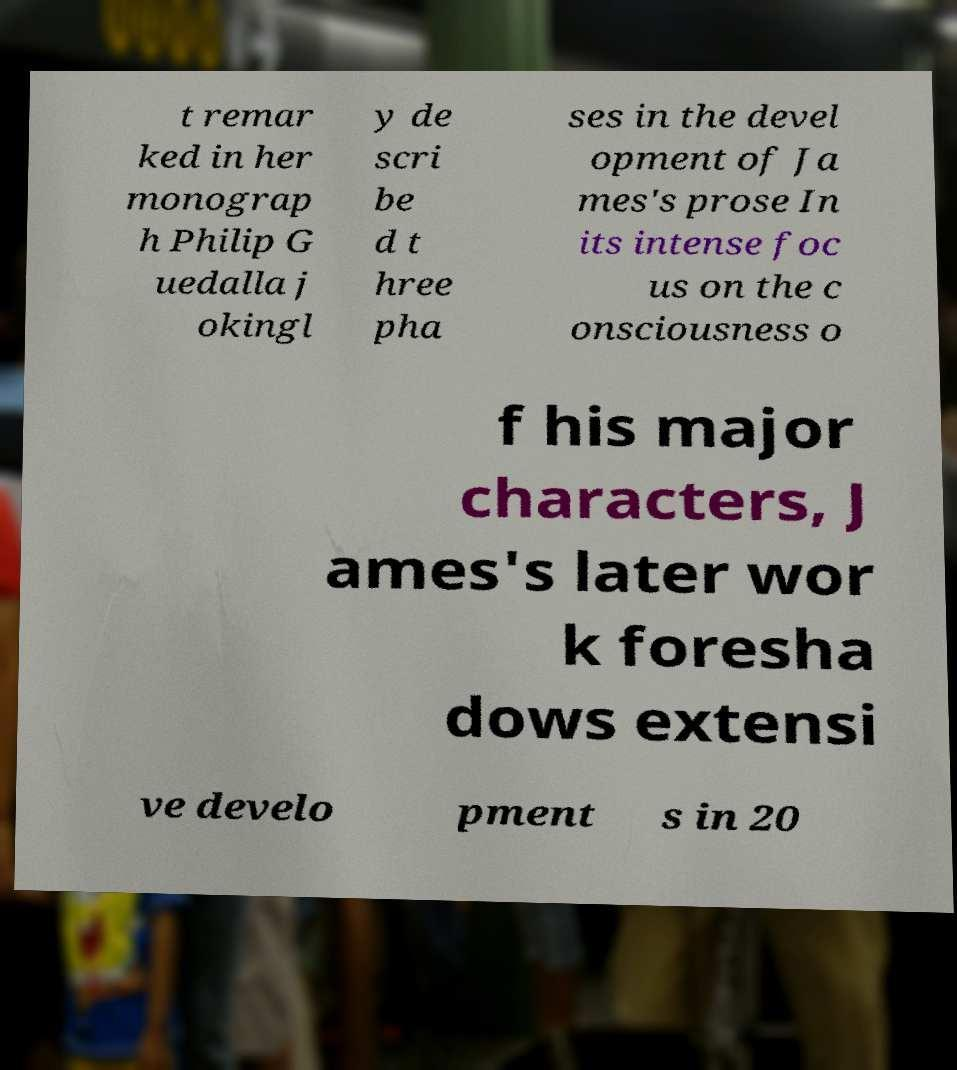I need the written content from this picture converted into text. Can you do that? t remar ked in her monograp h Philip G uedalla j okingl y de scri be d t hree pha ses in the devel opment of Ja mes's prose In its intense foc us on the c onsciousness o f his major characters, J ames's later wor k foresha dows extensi ve develo pment s in 20 